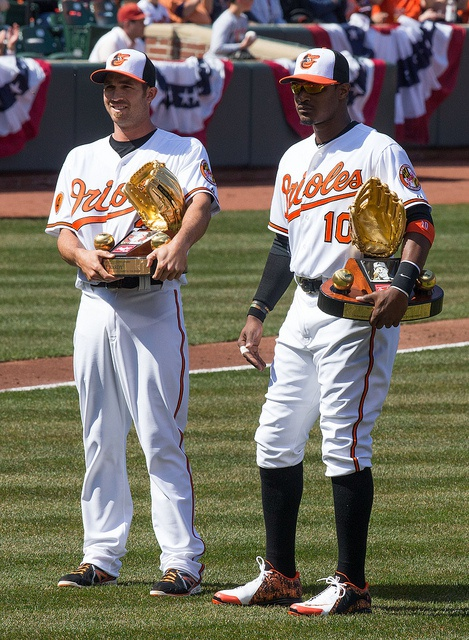Describe the objects in this image and their specific colors. I can see people in gray, black, white, and darkgray tones, people in gray, white, and darkgray tones, baseball glove in gray, maroon, olive, and tan tones, baseball glove in gray, olive, maroon, and tan tones, and people in gray, lightgray, and darkgray tones in this image. 